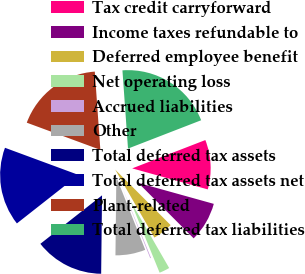Convert chart to OTSL. <chart><loc_0><loc_0><loc_500><loc_500><pie_chart><fcel>Tax credit carryforward<fcel>Income taxes refundable to<fcel>Deferred employee benefit<fcel>Net operating loss<fcel>Accrued liabilities<fcel>Other<fcel>Total deferred tax assets<fcel>Total deferred tax assets net<fcel>Plant-related<fcel>Total deferred tax liabilities<nl><fcel>10.2%<fcel>8.19%<fcel>4.17%<fcel>2.16%<fcel>0.16%<fcel>6.18%<fcel>14.22%<fcel>16.23%<fcel>18.24%<fcel>20.25%<nl></chart> 